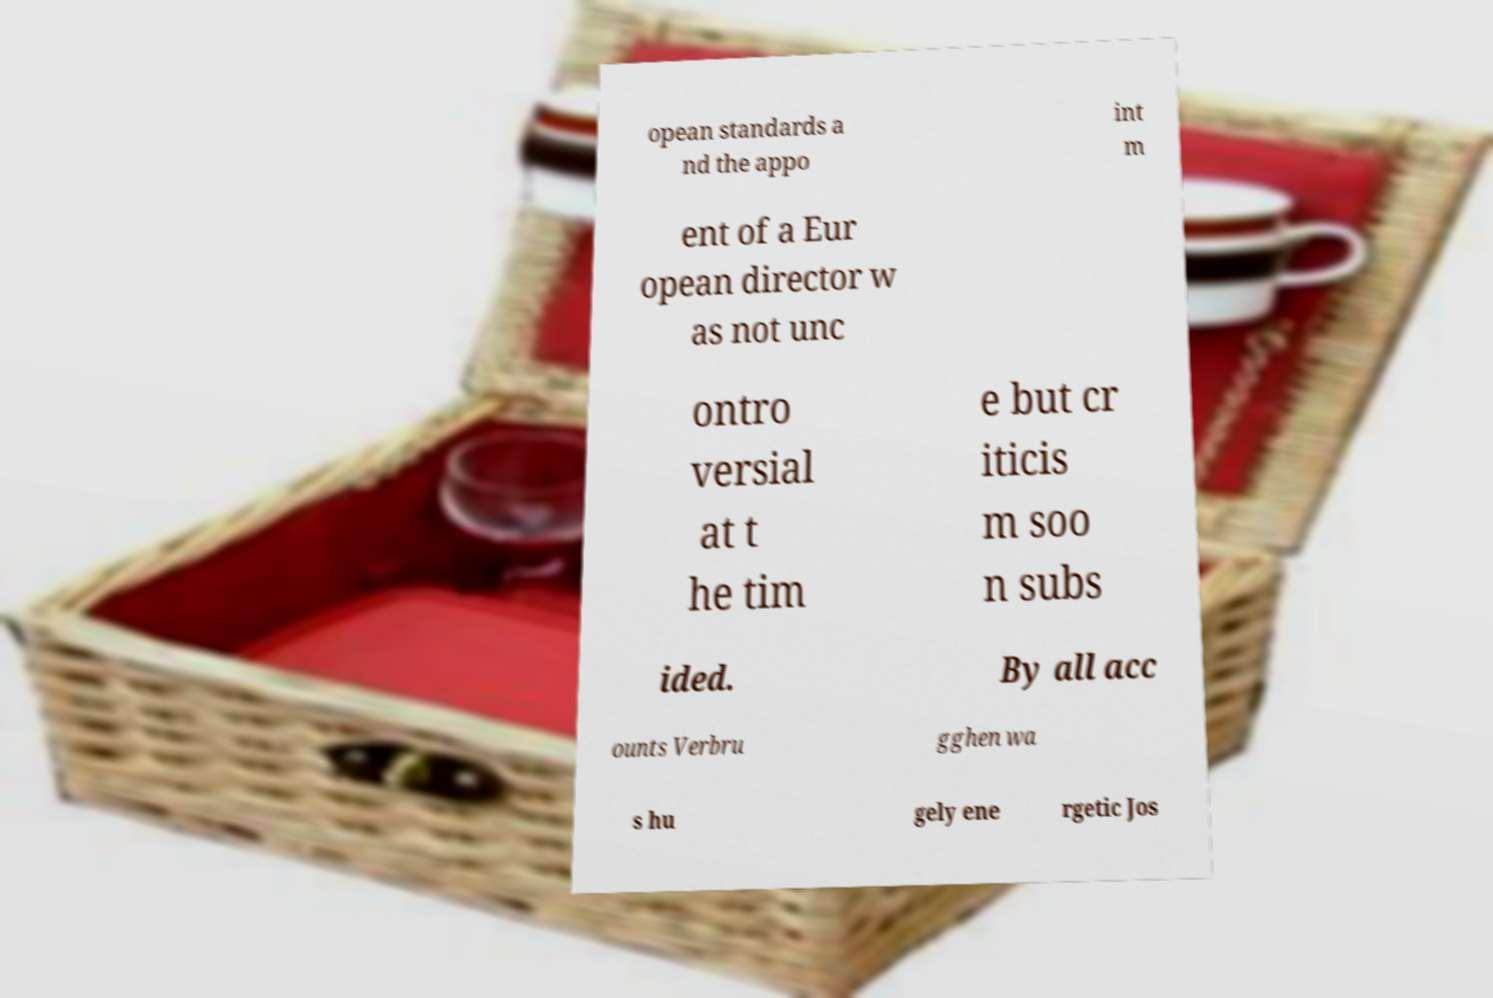There's text embedded in this image that I need extracted. Can you transcribe it verbatim? opean standards a nd the appo int m ent of a Eur opean director w as not unc ontro versial at t he tim e but cr iticis m soo n subs ided. By all acc ounts Verbru gghen wa s hu gely ene rgetic Jos 